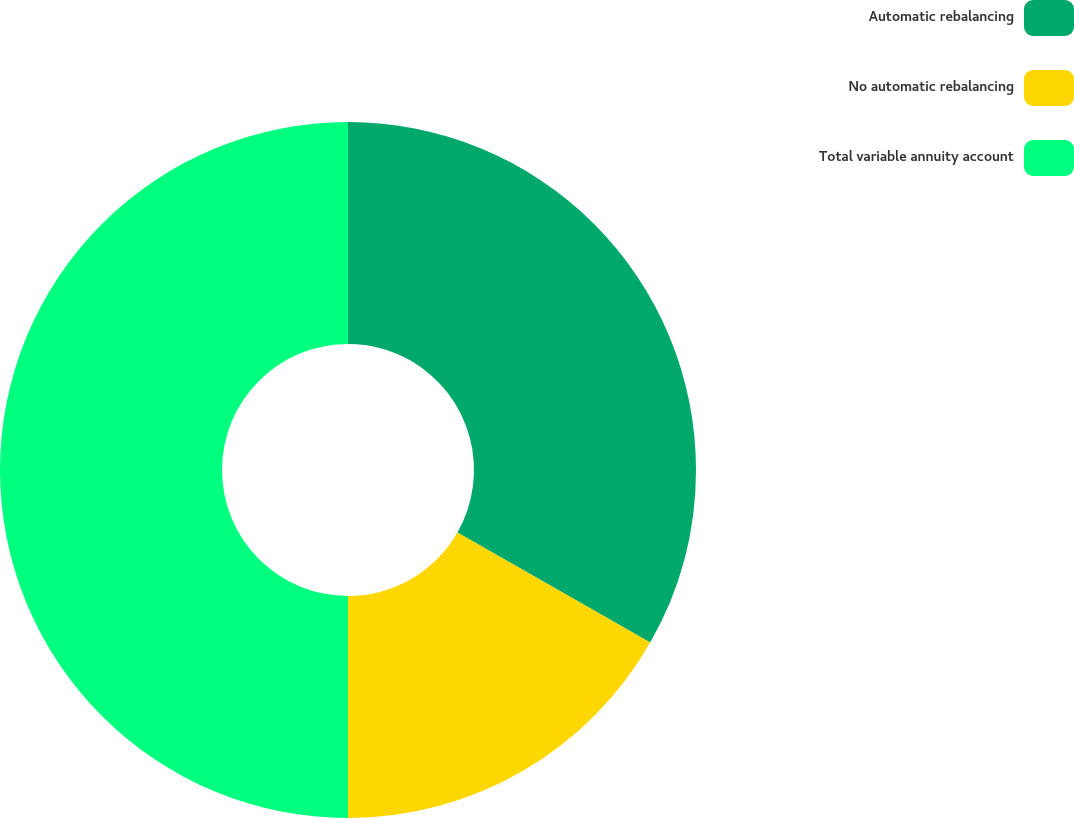<chart> <loc_0><loc_0><loc_500><loc_500><pie_chart><fcel>Automatic rebalancing<fcel>No automatic rebalancing<fcel>Total variable annuity account<nl><fcel>33.26%<fcel>16.74%<fcel>50.0%<nl></chart> 